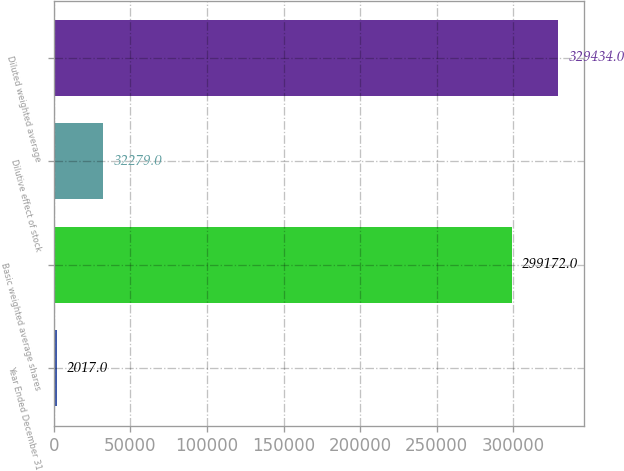<chart> <loc_0><loc_0><loc_500><loc_500><bar_chart><fcel>Year Ended December 31<fcel>Basic weighted average shares<fcel>Dilutive effect of stock<fcel>Diluted weighted average<nl><fcel>2017<fcel>299172<fcel>32279<fcel>329434<nl></chart> 